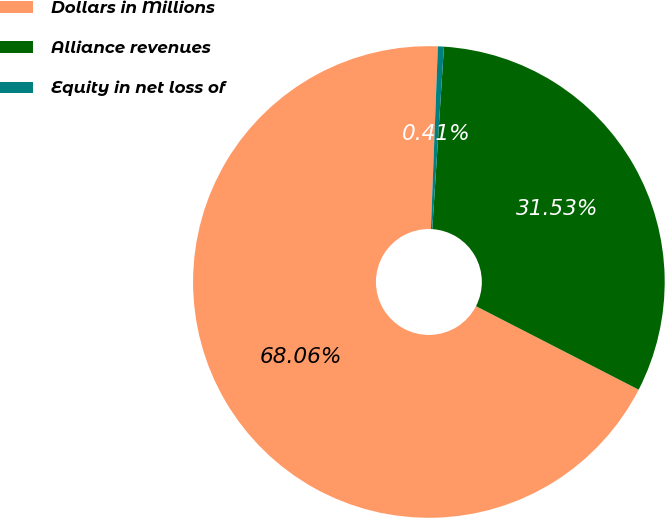Convert chart to OTSL. <chart><loc_0><loc_0><loc_500><loc_500><pie_chart><fcel>Dollars in Millions<fcel>Alliance revenues<fcel>Equity in net loss of<nl><fcel>68.06%<fcel>31.53%<fcel>0.41%<nl></chart> 